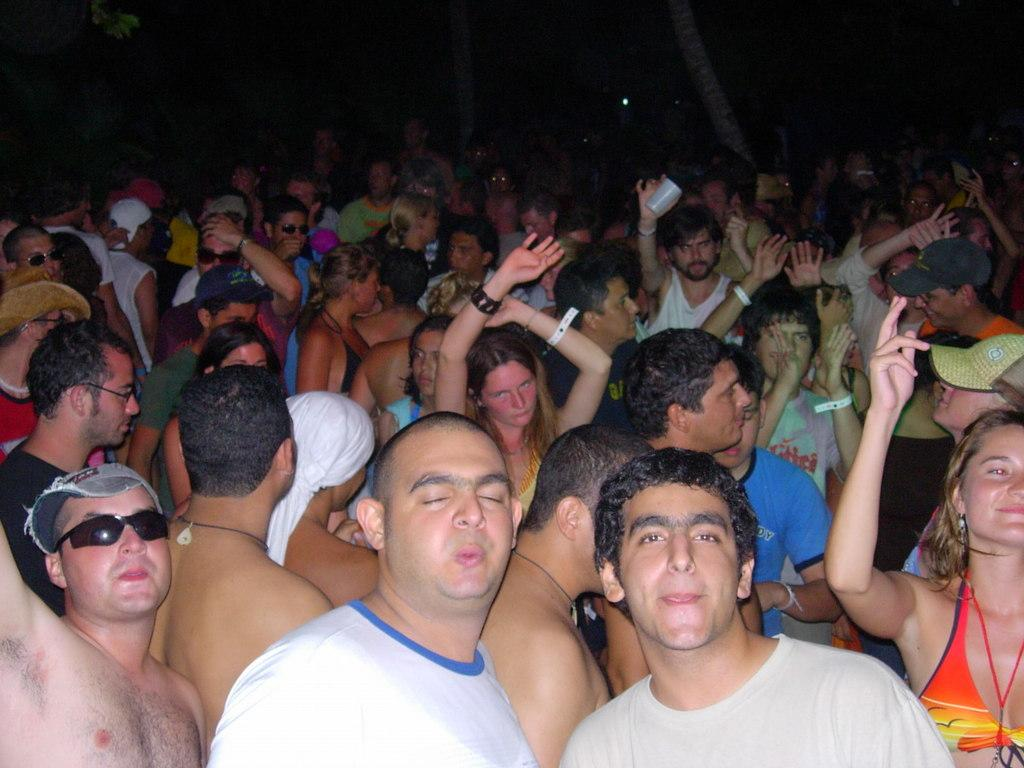How many people are in the image? There is a group of people in the image. What are the people in the image doing? The people are celebrating. What specific action are the people taking in the image? The people are raising their hands. What type of brass instrument is being played by one of the people in the image? There is no brass instrument present in the image. What type of suit is one of the people wearing in the image? There is no mention of anyone wearing a suit in the image. Where is the office where the people are celebrating located in the image? There is no office present in the image; it is a group of people celebrating. 